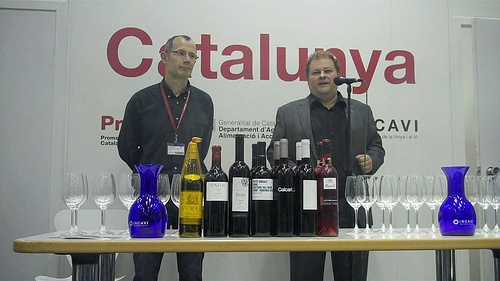Describe the objects in this image and their specific colors. I can see people in gray, black, and purple tones, people in gray, black, and purple tones, vase in gray, navy, darkblue, and blue tones, bottle in gray, olive, and black tones, and bottle in gray, black, darkgray, and lightgray tones in this image. 